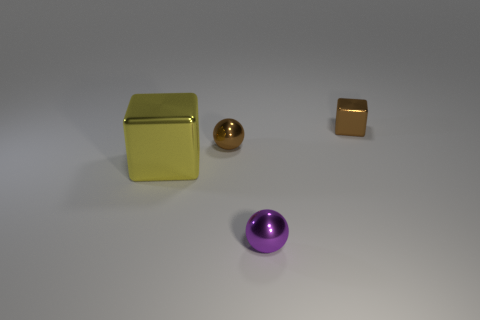Add 1 yellow blocks. How many objects exist? 5 Add 2 brown rubber objects. How many brown rubber objects exist? 2 Subtract 0 gray cubes. How many objects are left? 4 Subtract all big blocks. Subtract all brown metallic blocks. How many objects are left? 2 Add 1 purple metal spheres. How many purple metal spheres are left? 2 